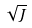Convert formula to latex. <formula><loc_0><loc_0><loc_500><loc_500>\sqrt { J }</formula> 